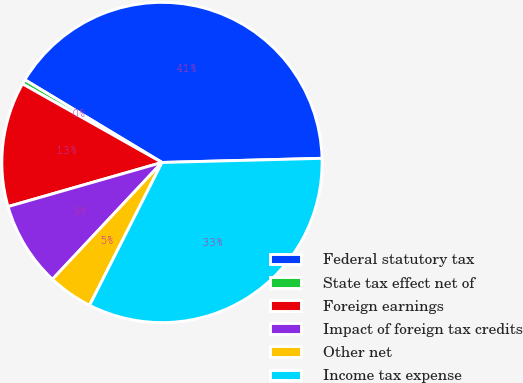<chart> <loc_0><loc_0><loc_500><loc_500><pie_chart><fcel>Federal statutory tax<fcel>State tax effect net of<fcel>Foreign earnings<fcel>Impact of foreign tax credits<fcel>Other net<fcel>Income tax expense<nl><fcel>40.95%<fcel>0.47%<fcel>12.61%<fcel>8.57%<fcel>4.52%<fcel>32.88%<nl></chart> 